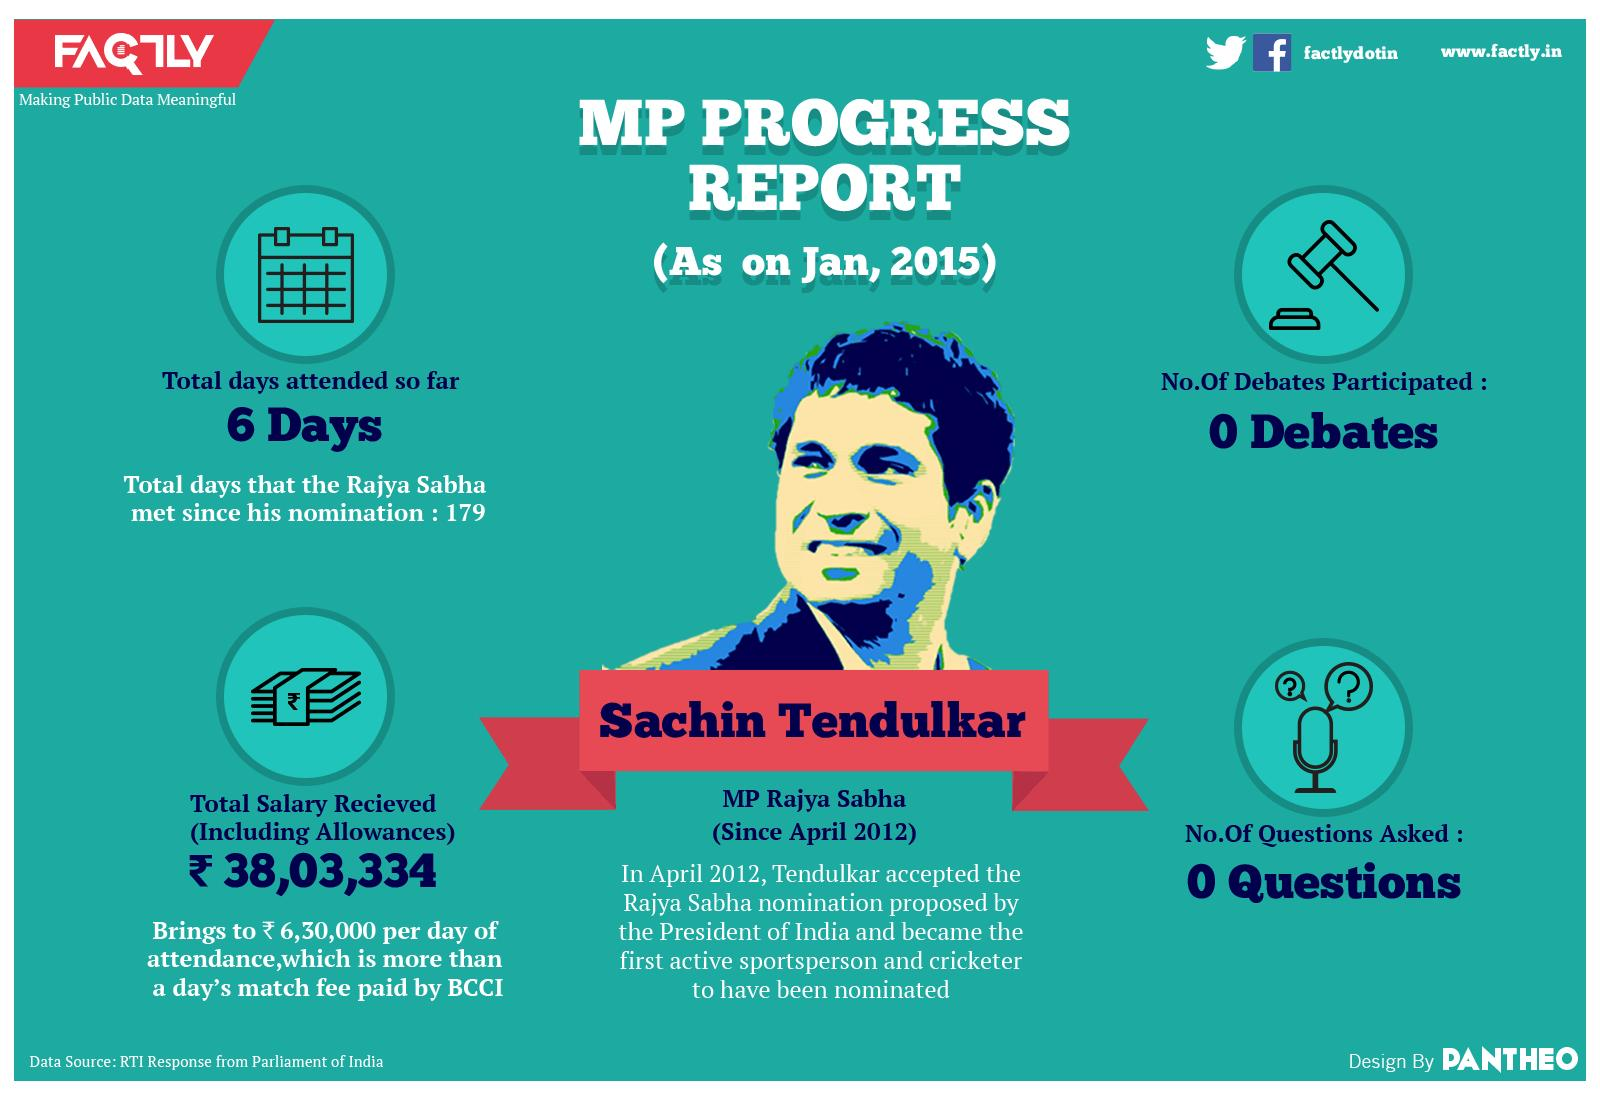Outline some significant characteristics in this image. The Rajya Sabha has met 173 times without Sachin Tendulkar being present. Sachin, an MP, received a salary of 6,30,000 Indian Rupees for a day. 